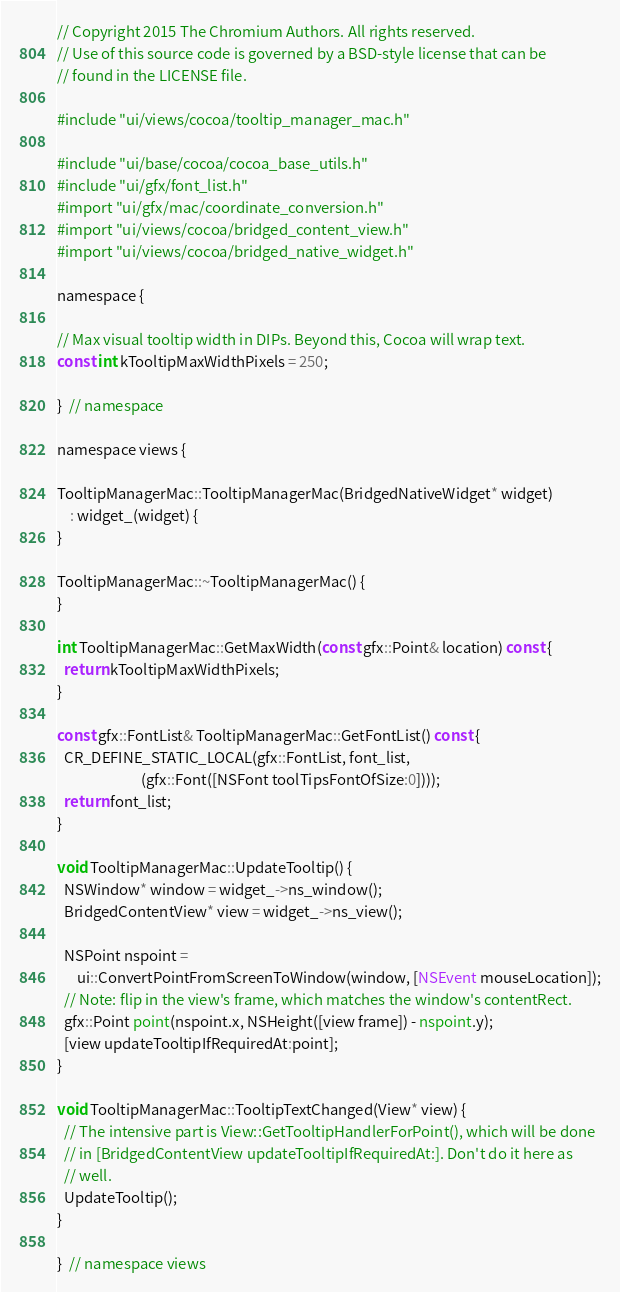Convert code to text. <code><loc_0><loc_0><loc_500><loc_500><_ObjectiveC_>// Copyright 2015 The Chromium Authors. All rights reserved.
// Use of this source code is governed by a BSD-style license that can be
// found in the LICENSE file.

#include "ui/views/cocoa/tooltip_manager_mac.h"

#include "ui/base/cocoa/cocoa_base_utils.h"
#include "ui/gfx/font_list.h"
#import "ui/gfx/mac/coordinate_conversion.h"
#import "ui/views/cocoa/bridged_content_view.h"
#import "ui/views/cocoa/bridged_native_widget.h"

namespace {

// Max visual tooltip width in DIPs. Beyond this, Cocoa will wrap text.
const int kTooltipMaxWidthPixels = 250;

}  // namespace

namespace views {

TooltipManagerMac::TooltipManagerMac(BridgedNativeWidget* widget)
    : widget_(widget) {
}

TooltipManagerMac::~TooltipManagerMac() {
}

int TooltipManagerMac::GetMaxWidth(const gfx::Point& location) const {
  return kTooltipMaxWidthPixels;
}

const gfx::FontList& TooltipManagerMac::GetFontList() const {
  CR_DEFINE_STATIC_LOCAL(gfx::FontList, font_list,
                         (gfx::Font([NSFont toolTipsFontOfSize:0])));
  return font_list;
}

void TooltipManagerMac::UpdateTooltip() {
  NSWindow* window = widget_->ns_window();
  BridgedContentView* view = widget_->ns_view();

  NSPoint nspoint =
      ui::ConvertPointFromScreenToWindow(window, [NSEvent mouseLocation]);
  // Note: flip in the view's frame, which matches the window's contentRect.
  gfx::Point point(nspoint.x, NSHeight([view frame]) - nspoint.y);
  [view updateTooltipIfRequiredAt:point];
}

void TooltipManagerMac::TooltipTextChanged(View* view) {
  // The intensive part is View::GetTooltipHandlerForPoint(), which will be done
  // in [BridgedContentView updateTooltipIfRequiredAt:]. Don't do it here as
  // well.
  UpdateTooltip();
}

}  // namespace views
</code> 